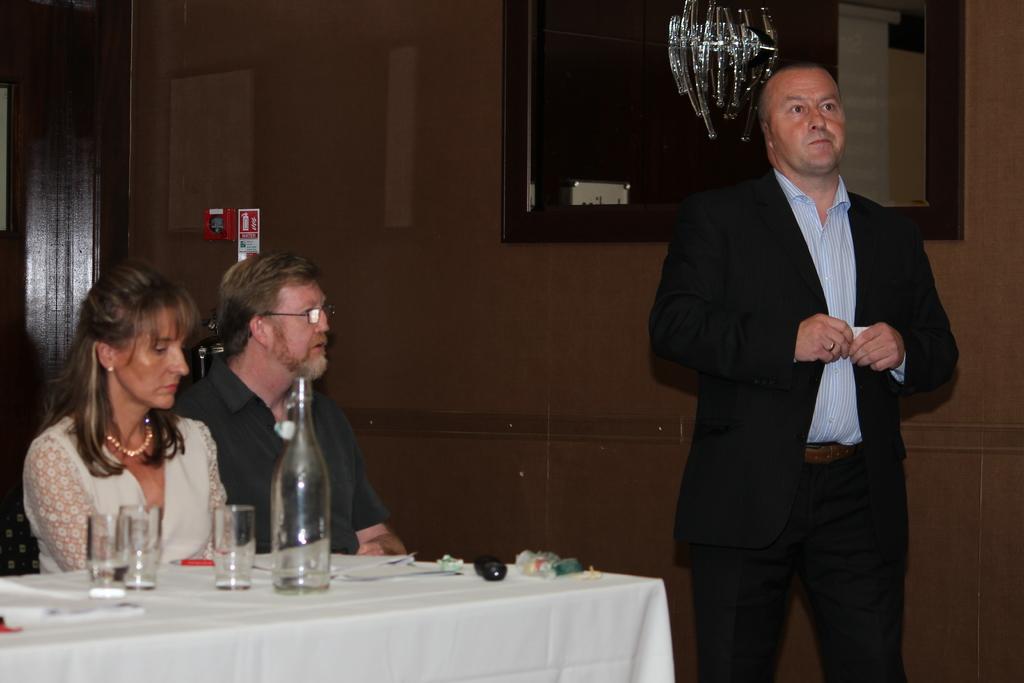Please provide a concise description of this image. This picture is clicked in a room. A man is standing towards the right, he is wearing a black blazer and black trousers. Towards the left there are two persons, one woman and one man sitting besides a table. Woman is wearing a white dress and man is wearing a black t shirt. In the background there is a wall, mirror and a cupboard. 